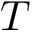Convert formula to latex. <formula><loc_0><loc_0><loc_500><loc_500>T</formula> 